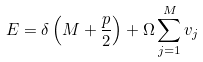Convert formula to latex. <formula><loc_0><loc_0><loc_500><loc_500>E = \delta \left ( M + \frac { p } { 2 } \right ) + \Omega \sum _ { j = 1 } ^ { M } v _ { j }</formula> 